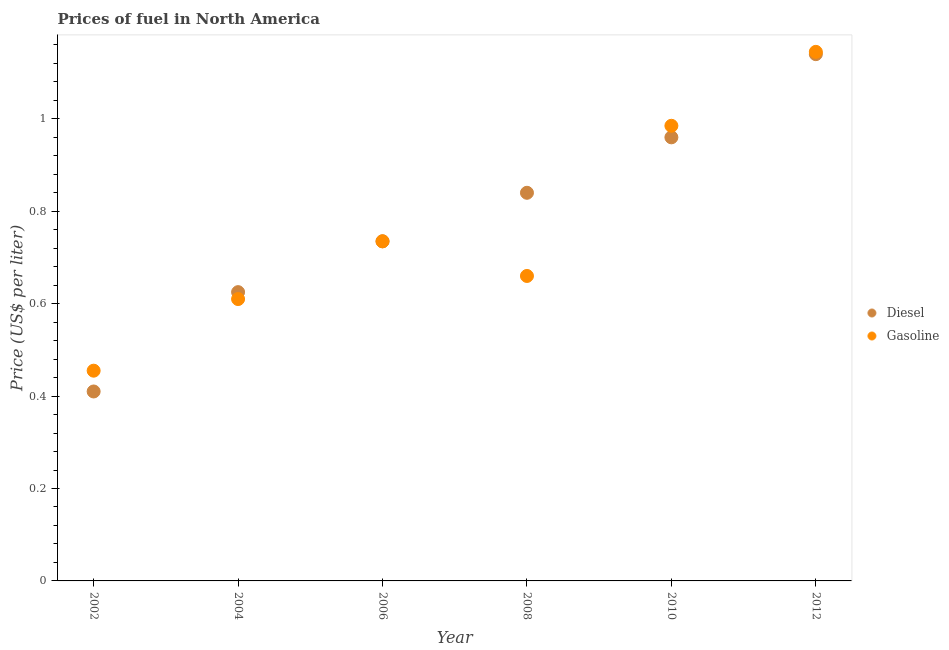How many different coloured dotlines are there?
Make the answer very short. 2. What is the diesel price in 2012?
Ensure brevity in your answer.  1.14. Across all years, what is the maximum gasoline price?
Offer a terse response. 1.15. Across all years, what is the minimum diesel price?
Keep it short and to the point. 0.41. In which year was the diesel price maximum?
Provide a short and direct response. 2012. In which year was the gasoline price minimum?
Provide a short and direct response. 2002. What is the total gasoline price in the graph?
Offer a terse response. 4.59. What is the difference between the gasoline price in 2004 and that in 2008?
Offer a terse response. -0.05. What is the difference between the gasoline price in 2010 and the diesel price in 2004?
Make the answer very short. 0.36. What is the average diesel price per year?
Provide a short and direct response. 0.79. In the year 2008, what is the difference between the gasoline price and diesel price?
Offer a very short reply. -0.18. In how many years, is the gasoline price greater than 0.16 US$ per litre?
Offer a very short reply. 6. What is the ratio of the gasoline price in 2008 to that in 2012?
Offer a very short reply. 0.58. Is the difference between the gasoline price in 2006 and 2010 greater than the difference between the diesel price in 2006 and 2010?
Keep it short and to the point. No. What is the difference between the highest and the second highest diesel price?
Provide a short and direct response. 0.18. What is the difference between the highest and the lowest diesel price?
Your answer should be compact. 0.73. Does the gasoline price monotonically increase over the years?
Your response must be concise. No. Is the diesel price strictly greater than the gasoline price over the years?
Offer a terse response. No. How many dotlines are there?
Your answer should be very brief. 2. How many years are there in the graph?
Your answer should be compact. 6. Are the values on the major ticks of Y-axis written in scientific E-notation?
Your answer should be compact. No. Does the graph contain grids?
Keep it short and to the point. No. How are the legend labels stacked?
Provide a short and direct response. Vertical. What is the title of the graph?
Make the answer very short. Prices of fuel in North America. Does "Number of arrivals" appear as one of the legend labels in the graph?
Give a very brief answer. No. What is the label or title of the Y-axis?
Provide a succinct answer. Price (US$ per liter). What is the Price (US$ per liter) in Diesel in 2002?
Offer a very short reply. 0.41. What is the Price (US$ per liter) in Gasoline in 2002?
Keep it short and to the point. 0.46. What is the Price (US$ per liter) of Gasoline in 2004?
Provide a short and direct response. 0.61. What is the Price (US$ per liter) of Diesel in 2006?
Make the answer very short. 0.73. What is the Price (US$ per liter) of Gasoline in 2006?
Your answer should be very brief. 0.73. What is the Price (US$ per liter) of Diesel in 2008?
Provide a succinct answer. 0.84. What is the Price (US$ per liter) in Gasoline in 2008?
Offer a terse response. 0.66. What is the Price (US$ per liter) in Diesel in 2010?
Offer a terse response. 0.96. What is the Price (US$ per liter) of Gasoline in 2010?
Give a very brief answer. 0.98. What is the Price (US$ per liter) in Diesel in 2012?
Give a very brief answer. 1.14. What is the Price (US$ per liter) of Gasoline in 2012?
Keep it short and to the point. 1.15. Across all years, what is the maximum Price (US$ per liter) in Diesel?
Offer a terse response. 1.14. Across all years, what is the maximum Price (US$ per liter) of Gasoline?
Give a very brief answer. 1.15. Across all years, what is the minimum Price (US$ per liter) of Diesel?
Provide a succinct answer. 0.41. Across all years, what is the minimum Price (US$ per liter) of Gasoline?
Keep it short and to the point. 0.46. What is the total Price (US$ per liter) in Diesel in the graph?
Your response must be concise. 4.71. What is the total Price (US$ per liter) of Gasoline in the graph?
Your response must be concise. 4.59. What is the difference between the Price (US$ per liter) of Diesel in 2002 and that in 2004?
Provide a succinct answer. -0.21. What is the difference between the Price (US$ per liter) of Gasoline in 2002 and that in 2004?
Your response must be concise. -0.15. What is the difference between the Price (US$ per liter) in Diesel in 2002 and that in 2006?
Your answer should be compact. -0.33. What is the difference between the Price (US$ per liter) in Gasoline in 2002 and that in 2006?
Offer a very short reply. -0.28. What is the difference between the Price (US$ per liter) of Diesel in 2002 and that in 2008?
Your response must be concise. -0.43. What is the difference between the Price (US$ per liter) in Gasoline in 2002 and that in 2008?
Your answer should be compact. -0.2. What is the difference between the Price (US$ per liter) of Diesel in 2002 and that in 2010?
Offer a terse response. -0.55. What is the difference between the Price (US$ per liter) in Gasoline in 2002 and that in 2010?
Ensure brevity in your answer.  -0.53. What is the difference between the Price (US$ per liter) in Diesel in 2002 and that in 2012?
Keep it short and to the point. -0.73. What is the difference between the Price (US$ per liter) in Gasoline in 2002 and that in 2012?
Your response must be concise. -0.69. What is the difference between the Price (US$ per liter) in Diesel in 2004 and that in 2006?
Offer a terse response. -0.11. What is the difference between the Price (US$ per liter) of Gasoline in 2004 and that in 2006?
Make the answer very short. -0.12. What is the difference between the Price (US$ per liter) of Diesel in 2004 and that in 2008?
Ensure brevity in your answer.  -0.21. What is the difference between the Price (US$ per liter) of Gasoline in 2004 and that in 2008?
Your response must be concise. -0.05. What is the difference between the Price (US$ per liter) in Diesel in 2004 and that in 2010?
Provide a succinct answer. -0.34. What is the difference between the Price (US$ per liter) in Gasoline in 2004 and that in 2010?
Keep it short and to the point. -0.38. What is the difference between the Price (US$ per liter) in Diesel in 2004 and that in 2012?
Your answer should be very brief. -0.52. What is the difference between the Price (US$ per liter) of Gasoline in 2004 and that in 2012?
Keep it short and to the point. -0.54. What is the difference between the Price (US$ per liter) in Diesel in 2006 and that in 2008?
Make the answer very short. -0.1. What is the difference between the Price (US$ per liter) of Gasoline in 2006 and that in 2008?
Keep it short and to the point. 0.07. What is the difference between the Price (US$ per liter) of Diesel in 2006 and that in 2010?
Provide a short and direct response. -0.23. What is the difference between the Price (US$ per liter) of Gasoline in 2006 and that in 2010?
Offer a terse response. -0.25. What is the difference between the Price (US$ per liter) of Diesel in 2006 and that in 2012?
Ensure brevity in your answer.  -0.41. What is the difference between the Price (US$ per liter) in Gasoline in 2006 and that in 2012?
Give a very brief answer. -0.41. What is the difference between the Price (US$ per liter) of Diesel in 2008 and that in 2010?
Make the answer very short. -0.12. What is the difference between the Price (US$ per liter) in Gasoline in 2008 and that in 2010?
Provide a succinct answer. -0.33. What is the difference between the Price (US$ per liter) in Diesel in 2008 and that in 2012?
Ensure brevity in your answer.  -0.3. What is the difference between the Price (US$ per liter) in Gasoline in 2008 and that in 2012?
Ensure brevity in your answer.  -0.48. What is the difference between the Price (US$ per liter) in Diesel in 2010 and that in 2012?
Make the answer very short. -0.18. What is the difference between the Price (US$ per liter) in Gasoline in 2010 and that in 2012?
Your answer should be very brief. -0.16. What is the difference between the Price (US$ per liter) in Diesel in 2002 and the Price (US$ per liter) in Gasoline in 2006?
Provide a succinct answer. -0.33. What is the difference between the Price (US$ per liter) in Diesel in 2002 and the Price (US$ per liter) in Gasoline in 2008?
Give a very brief answer. -0.25. What is the difference between the Price (US$ per liter) in Diesel in 2002 and the Price (US$ per liter) in Gasoline in 2010?
Your response must be concise. -0.57. What is the difference between the Price (US$ per liter) in Diesel in 2002 and the Price (US$ per liter) in Gasoline in 2012?
Make the answer very short. -0.73. What is the difference between the Price (US$ per liter) of Diesel in 2004 and the Price (US$ per liter) of Gasoline in 2006?
Make the answer very short. -0.11. What is the difference between the Price (US$ per liter) of Diesel in 2004 and the Price (US$ per liter) of Gasoline in 2008?
Provide a succinct answer. -0.04. What is the difference between the Price (US$ per liter) of Diesel in 2004 and the Price (US$ per liter) of Gasoline in 2010?
Make the answer very short. -0.36. What is the difference between the Price (US$ per liter) of Diesel in 2004 and the Price (US$ per liter) of Gasoline in 2012?
Offer a very short reply. -0.52. What is the difference between the Price (US$ per liter) in Diesel in 2006 and the Price (US$ per liter) in Gasoline in 2008?
Offer a very short reply. 0.07. What is the difference between the Price (US$ per liter) in Diesel in 2006 and the Price (US$ per liter) in Gasoline in 2012?
Your answer should be compact. -0.41. What is the difference between the Price (US$ per liter) in Diesel in 2008 and the Price (US$ per liter) in Gasoline in 2010?
Your response must be concise. -0.14. What is the difference between the Price (US$ per liter) of Diesel in 2008 and the Price (US$ per liter) of Gasoline in 2012?
Your response must be concise. -0.3. What is the difference between the Price (US$ per liter) in Diesel in 2010 and the Price (US$ per liter) in Gasoline in 2012?
Keep it short and to the point. -0.18. What is the average Price (US$ per liter) of Diesel per year?
Your answer should be compact. 0.79. What is the average Price (US$ per liter) in Gasoline per year?
Provide a short and direct response. 0.77. In the year 2002, what is the difference between the Price (US$ per liter) in Diesel and Price (US$ per liter) in Gasoline?
Keep it short and to the point. -0.04. In the year 2004, what is the difference between the Price (US$ per liter) in Diesel and Price (US$ per liter) in Gasoline?
Offer a very short reply. 0.01. In the year 2006, what is the difference between the Price (US$ per liter) of Diesel and Price (US$ per liter) of Gasoline?
Your answer should be compact. 0. In the year 2008, what is the difference between the Price (US$ per liter) of Diesel and Price (US$ per liter) of Gasoline?
Give a very brief answer. 0.18. In the year 2010, what is the difference between the Price (US$ per liter) of Diesel and Price (US$ per liter) of Gasoline?
Provide a succinct answer. -0.03. In the year 2012, what is the difference between the Price (US$ per liter) of Diesel and Price (US$ per liter) of Gasoline?
Ensure brevity in your answer.  -0.01. What is the ratio of the Price (US$ per liter) in Diesel in 2002 to that in 2004?
Give a very brief answer. 0.66. What is the ratio of the Price (US$ per liter) in Gasoline in 2002 to that in 2004?
Provide a short and direct response. 0.75. What is the ratio of the Price (US$ per liter) of Diesel in 2002 to that in 2006?
Ensure brevity in your answer.  0.56. What is the ratio of the Price (US$ per liter) of Gasoline in 2002 to that in 2006?
Make the answer very short. 0.62. What is the ratio of the Price (US$ per liter) of Diesel in 2002 to that in 2008?
Give a very brief answer. 0.49. What is the ratio of the Price (US$ per liter) in Gasoline in 2002 to that in 2008?
Offer a very short reply. 0.69. What is the ratio of the Price (US$ per liter) of Diesel in 2002 to that in 2010?
Provide a succinct answer. 0.43. What is the ratio of the Price (US$ per liter) of Gasoline in 2002 to that in 2010?
Provide a short and direct response. 0.46. What is the ratio of the Price (US$ per liter) of Diesel in 2002 to that in 2012?
Give a very brief answer. 0.36. What is the ratio of the Price (US$ per liter) of Gasoline in 2002 to that in 2012?
Give a very brief answer. 0.4. What is the ratio of the Price (US$ per liter) of Diesel in 2004 to that in 2006?
Give a very brief answer. 0.85. What is the ratio of the Price (US$ per liter) in Gasoline in 2004 to that in 2006?
Provide a succinct answer. 0.83. What is the ratio of the Price (US$ per liter) of Diesel in 2004 to that in 2008?
Your response must be concise. 0.74. What is the ratio of the Price (US$ per liter) of Gasoline in 2004 to that in 2008?
Your answer should be compact. 0.92. What is the ratio of the Price (US$ per liter) of Diesel in 2004 to that in 2010?
Offer a very short reply. 0.65. What is the ratio of the Price (US$ per liter) in Gasoline in 2004 to that in 2010?
Offer a terse response. 0.62. What is the ratio of the Price (US$ per liter) in Diesel in 2004 to that in 2012?
Your answer should be very brief. 0.55. What is the ratio of the Price (US$ per liter) of Gasoline in 2004 to that in 2012?
Offer a terse response. 0.53. What is the ratio of the Price (US$ per liter) of Diesel in 2006 to that in 2008?
Keep it short and to the point. 0.88. What is the ratio of the Price (US$ per liter) in Gasoline in 2006 to that in 2008?
Give a very brief answer. 1.11. What is the ratio of the Price (US$ per liter) of Diesel in 2006 to that in 2010?
Provide a succinct answer. 0.77. What is the ratio of the Price (US$ per liter) of Gasoline in 2006 to that in 2010?
Ensure brevity in your answer.  0.75. What is the ratio of the Price (US$ per liter) of Diesel in 2006 to that in 2012?
Your answer should be very brief. 0.64. What is the ratio of the Price (US$ per liter) of Gasoline in 2006 to that in 2012?
Your answer should be compact. 0.64. What is the ratio of the Price (US$ per liter) of Diesel in 2008 to that in 2010?
Offer a very short reply. 0.88. What is the ratio of the Price (US$ per liter) in Gasoline in 2008 to that in 2010?
Your response must be concise. 0.67. What is the ratio of the Price (US$ per liter) in Diesel in 2008 to that in 2012?
Offer a very short reply. 0.74. What is the ratio of the Price (US$ per liter) of Gasoline in 2008 to that in 2012?
Give a very brief answer. 0.58. What is the ratio of the Price (US$ per liter) in Diesel in 2010 to that in 2012?
Provide a short and direct response. 0.84. What is the ratio of the Price (US$ per liter) of Gasoline in 2010 to that in 2012?
Make the answer very short. 0.86. What is the difference between the highest and the second highest Price (US$ per liter) of Diesel?
Your answer should be very brief. 0.18. What is the difference between the highest and the second highest Price (US$ per liter) of Gasoline?
Give a very brief answer. 0.16. What is the difference between the highest and the lowest Price (US$ per liter) of Diesel?
Ensure brevity in your answer.  0.73. What is the difference between the highest and the lowest Price (US$ per liter) of Gasoline?
Offer a terse response. 0.69. 